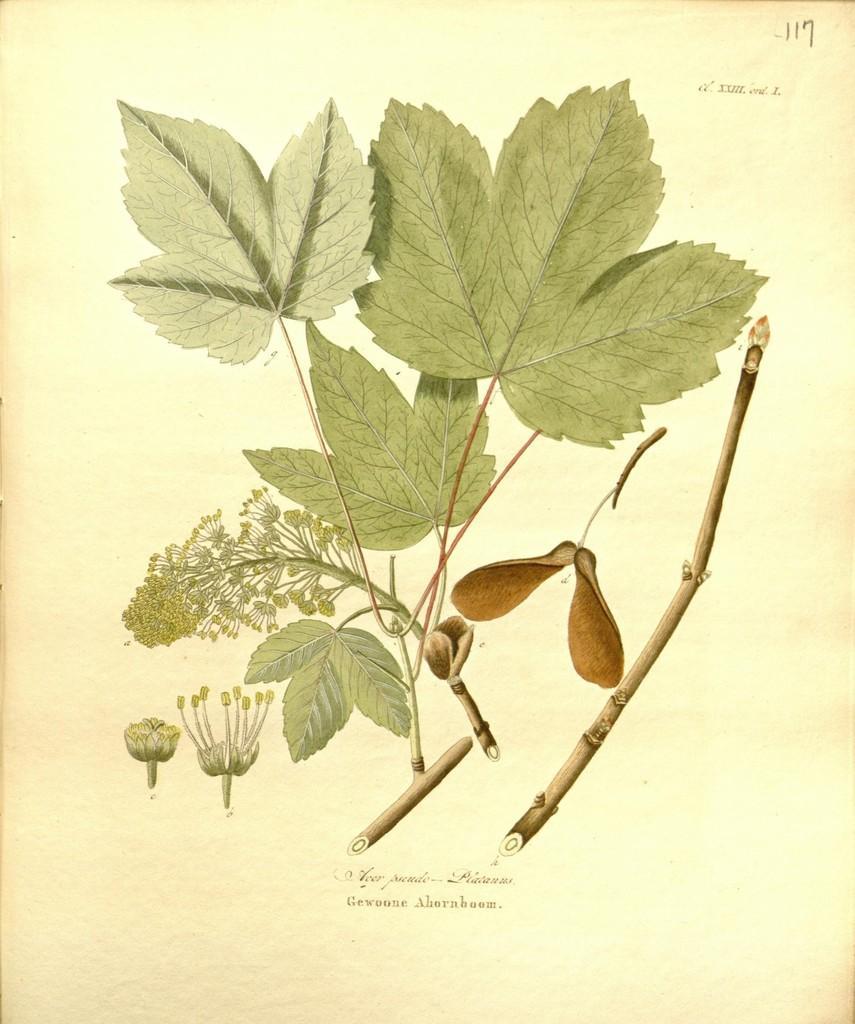Could you give a brief overview of what you see in this image? In the image we can see a paper, in the paper we can see some leaves and stems and flowers. 